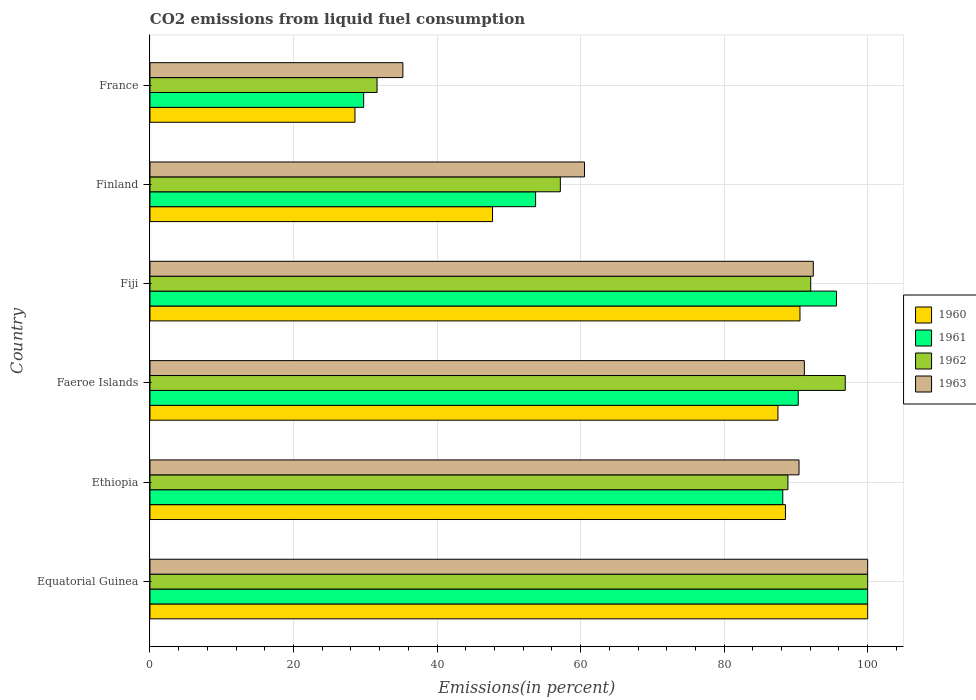How many groups of bars are there?
Make the answer very short. 6. Are the number of bars on each tick of the Y-axis equal?
Keep it short and to the point. Yes. How many bars are there on the 3rd tick from the bottom?
Give a very brief answer. 4. What is the label of the 3rd group of bars from the top?
Keep it short and to the point. Fiji. In how many cases, is the number of bars for a given country not equal to the number of legend labels?
Provide a succinct answer. 0. What is the total CO2 emitted in 1963 in France?
Offer a terse response. 35.24. Across all countries, what is the maximum total CO2 emitted in 1960?
Your response must be concise. 100. Across all countries, what is the minimum total CO2 emitted in 1962?
Offer a very short reply. 31.64. In which country was the total CO2 emitted in 1962 maximum?
Make the answer very short. Equatorial Guinea. In which country was the total CO2 emitted in 1962 minimum?
Provide a succinct answer. France. What is the total total CO2 emitted in 1960 in the graph?
Ensure brevity in your answer.  442.9. What is the difference between the total CO2 emitted in 1962 in Finland and that in France?
Make the answer very short. 25.54. What is the difference between the total CO2 emitted in 1960 in Fiji and the total CO2 emitted in 1962 in Finland?
Your answer should be compact. 33.39. What is the average total CO2 emitted in 1963 per country?
Provide a short and direct response. 78.3. What is the difference between the total CO2 emitted in 1961 and total CO2 emitted in 1962 in Finland?
Your response must be concise. -3.45. In how many countries, is the total CO2 emitted in 1963 greater than 28 %?
Your answer should be very brief. 6. What is the ratio of the total CO2 emitted in 1960 in Equatorial Guinea to that in France?
Give a very brief answer. 3.5. Is the total CO2 emitted in 1960 in Finland less than that in France?
Offer a terse response. No. Is the difference between the total CO2 emitted in 1961 in Equatorial Guinea and Fiji greater than the difference between the total CO2 emitted in 1962 in Equatorial Guinea and Fiji?
Ensure brevity in your answer.  No. What is the difference between the highest and the second highest total CO2 emitted in 1961?
Offer a very short reply. 4.35. What is the difference between the highest and the lowest total CO2 emitted in 1962?
Provide a succinct answer. 68.36. In how many countries, is the total CO2 emitted in 1961 greater than the average total CO2 emitted in 1961 taken over all countries?
Give a very brief answer. 4. What does the 4th bar from the top in Fiji represents?
Give a very brief answer. 1960. Is it the case that in every country, the sum of the total CO2 emitted in 1960 and total CO2 emitted in 1962 is greater than the total CO2 emitted in 1963?
Make the answer very short. Yes. How many bars are there?
Keep it short and to the point. 24. How many countries are there in the graph?
Make the answer very short. 6. Does the graph contain any zero values?
Give a very brief answer. No. Does the graph contain grids?
Provide a succinct answer. Yes. Where does the legend appear in the graph?
Offer a terse response. Center right. What is the title of the graph?
Ensure brevity in your answer.  CO2 emissions from liquid fuel consumption. Does "2003" appear as one of the legend labels in the graph?
Keep it short and to the point. No. What is the label or title of the X-axis?
Make the answer very short. Emissions(in percent). What is the label or title of the Y-axis?
Provide a short and direct response. Country. What is the Emissions(in percent) of 1961 in Equatorial Guinea?
Your answer should be compact. 100. What is the Emissions(in percent) of 1960 in Ethiopia?
Provide a short and direct response. 88.54. What is the Emissions(in percent) of 1961 in Ethiopia?
Provide a succinct answer. 88.17. What is the Emissions(in percent) in 1962 in Ethiopia?
Ensure brevity in your answer.  88.89. What is the Emissions(in percent) in 1963 in Ethiopia?
Your answer should be very brief. 90.43. What is the Emissions(in percent) in 1960 in Faeroe Islands?
Offer a very short reply. 87.5. What is the Emissions(in percent) of 1961 in Faeroe Islands?
Your response must be concise. 90.32. What is the Emissions(in percent) of 1962 in Faeroe Islands?
Offer a very short reply. 96.88. What is the Emissions(in percent) in 1963 in Faeroe Islands?
Provide a succinct answer. 91.18. What is the Emissions(in percent) of 1960 in Fiji?
Offer a very short reply. 90.57. What is the Emissions(in percent) in 1961 in Fiji?
Your response must be concise. 95.65. What is the Emissions(in percent) in 1962 in Fiji?
Ensure brevity in your answer.  92.06. What is the Emissions(in percent) in 1963 in Fiji?
Offer a very short reply. 92.42. What is the Emissions(in percent) of 1960 in Finland?
Offer a terse response. 47.73. What is the Emissions(in percent) of 1961 in Finland?
Keep it short and to the point. 53.73. What is the Emissions(in percent) in 1962 in Finland?
Provide a short and direct response. 57.18. What is the Emissions(in percent) in 1963 in Finland?
Give a very brief answer. 60.54. What is the Emissions(in percent) of 1960 in France?
Offer a terse response. 28.56. What is the Emissions(in percent) of 1961 in France?
Provide a short and direct response. 29.77. What is the Emissions(in percent) of 1962 in France?
Your answer should be very brief. 31.64. What is the Emissions(in percent) in 1963 in France?
Provide a short and direct response. 35.24. Across all countries, what is the maximum Emissions(in percent) of 1960?
Ensure brevity in your answer.  100. Across all countries, what is the maximum Emissions(in percent) of 1961?
Ensure brevity in your answer.  100. Across all countries, what is the maximum Emissions(in percent) of 1963?
Your response must be concise. 100. Across all countries, what is the minimum Emissions(in percent) in 1960?
Ensure brevity in your answer.  28.56. Across all countries, what is the minimum Emissions(in percent) in 1961?
Your response must be concise. 29.77. Across all countries, what is the minimum Emissions(in percent) of 1962?
Make the answer very short. 31.64. Across all countries, what is the minimum Emissions(in percent) in 1963?
Give a very brief answer. 35.24. What is the total Emissions(in percent) of 1960 in the graph?
Provide a short and direct response. 442.9. What is the total Emissions(in percent) in 1961 in the graph?
Your answer should be compact. 457.65. What is the total Emissions(in percent) of 1962 in the graph?
Provide a succinct answer. 466.64. What is the total Emissions(in percent) of 1963 in the graph?
Provide a succinct answer. 469.82. What is the difference between the Emissions(in percent) in 1960 in Equatorial Guinea and that in Ethiopia?
Offer a very short reply. 11.46. What is the difference between the Emissions(in percent) of 1961 in Equatorial Guinea and that in Ethiopia?
Keep it short and to the point. 11.83. What is the difference between the Emissions(in percent) in 1962 in Equatorial Guinea and that in Ethiopia?
Provide a short and direct response. 11.11. What is the difference between the Emissions(in percent) of 1963 in Equatorial Guinea and that in Ethiopia?
Make the answer very short. 9.57. What is the difference between the Emissions(in percent) in 1960 in Equatorial Guinea and that in Faeroe Islands?
Offer a terse response. 12.5. What is the difference between the Emissions(in percent) of 1961 in Equatorial Guinea and that in Faeroe Islands?
Offer a very short reply. 9.68. What is the difference between the Emissions(in percent) of 1962 in Equatorial Guinea and that in Faeroe Islands?
Make the answer very short. 3.12. What is the difference between the Emissions(in percent) of 1963 in Equatorial Guinea and that in Faeroe Islands?
Offer a terse response. 8.82. What is the difference between the Emissions(in percent) in 1960 in Equatorial Guinea and that in Fiji?
Offer a very short reply. 9.43. What is the difference between the Emissions(in percent) in 1961 in Equatorial Guinea and that in Fiji?
Offer a very short reply. 4.35. What is the difference between the Emissions(in percent) of 1962 in Equatorial Guinea and that in Fiji?
Make the answer very short. 7.94. What is the difference between the Emissions(in percent) in 1963 in Equatorial Guinea and that in Fiji?
Give a very brief answer. 7.58. What is the difference between the Emissions(in percent) of 1960 in Equatorial Guinea and that in Finland?
Ensure brevity in your answer.  52.27. What is the difference between the Emissions(in percent) of 1961 in Equatorial Guinea and that in Finland?
Provide a succinct answer. 46.27. What is the difference between the Emissions(in percent) in 1962 in Equatorial Guinea and that in Finland?
Provide a short and direct response. 42.82. What is the difference between the Emissions(in percent) of 1963 in Equatorial Guinea and that in Finland?
Offer a terse response. 39.46. What is the difference between the Emissions(in percent) in 1960 in Equatorial Guinea and that in France?
Your response must be concise. 71.44. What is the difference between the Emissions(in percent) of 1961 in Equatorial Guinea and that in France?
Your response must be concise. 70.23. What is the difference between the Emissions(in percent) in 1962 in Equatorial Guinea and that in France?
Ensure brevity in your answer.  68.36. What is the difference between the Emissions(in percent) of 1963 in Equatorial Guinea and that in France?
Your response must be concise. 64.76. What is the difference between the Emissions(in percent) of 1960 in Ethiopia and that in Faeroe Islands?
Ensure brevity in your answer.  1.04. What is the difference between the Emissions(in percent) in 1961 in Ethiopia and that in Faeroe Islands?
Keep it short and to the point. -2.15. What is the difference between the Emissions(in percent) in 1962 in Ethiopia and that in Faeroe Islands?
Your answer should be compact. -7.99. What is the difference between the Emissions(in percent) of 1963 in Ethiopia and that in Faeroe Islands?
Keep it short and to the point. -0.74. What is the difference between the Emissions(in percent) in 1960 in Ethiopia and that in Fiji?
Your answer should be compact. -2.02. What is the difference between the Emissions(in percent) in 1961 in Ethiopia and that in Fiji?
Your response must be concise. -7.48. What is the difference between the Emissions(in percent) in 1962 in Ethiopia and that in Fiji?
Your answer should be compact. -3.17. What is the difference between the Emissions(in percent) of 1963 in Ethiopia and that in Fiji?
Offer a very short reply. -1.99. What is the difference between the Emissions(in percent) in 1960 in Ethiopia and that in Finland?
Provide a short and direct response. 40.81. What is the difference between the Emissions(in percent) of 1961 in Ethiopia and that in Finland?
Ensure brevity in your answer.  34.44. What is the difference between the Emissions(in percent) in 1962 in Ethiopia and that in Finland?
Give a very brief answer. 31.71. What is the difference between the Emissions(in percent) in 1963 in Ethiopia and that in Finland?
Provide a succinct answer. 29.89. What is the difference between the Emissions(in percent) of 1960 in Ethiopia and that in France?
Offer a terse response. 59.98. What is the difference between the Emissions(in percent) in 1961 in Ethiopia and that in France?
Keep it short and to the point. 58.4. What is the difference between the Emissions(in percent) of 1962 in Ethiopia and that in France?
Offer a very short reply. 57.25. What is the difference between the Emissions(in percent) in 1963 in Ethiopia and that in France?
Provide a succinct answer. 55.2. What is the difference between the Emissions(in percent) in 1960 in Faeroe Islands and that in Fiji?
Your answer should be very brief. -3.07. What is the difference between the Emissions(in percent) in 1961 in Faeroe Islands and that in Fiji?
Provide a succinct answer. -5.33. What is the difference between the Emissions(in percent) in 1962 in Faeroe Islands and that in Fiji?
Offer a terse response. 4.81. What is the difference between the Emissions(in percent) in 1963 in Faeroe Islands and that in Fiji?
Make the answer very short. -1.25. What is the difference between the Emissions(in percent) in 1960 in Faeroe Islands and that in Finland?
Your answer should be compact. 39.77. What is the difference between the Emissions(in percent) in 1961 in Faeroe Islands and that in Finland?
Your answer should be compact. 36.59. What is the difference between the Emissions(in percent) in 1962 in Faeroe Islands and that in Finland?
Your answer should be compact. 39.7. What is the difference between the Emissions(in percent) in 1963 in Faeroe Islands and that in Finland?
Your response must be concise. 30.63. What is the difference between the Emissions(in percent) of 1960 in Faeroe Islands and that in France?
Your answer should be compact. 58.94. What is the difference between the Emissions(in percent) of 1961 in Faeroe Islands and that in France?
Your answer should be compact. 60.55. What is the difference between the Emissions(in percent) in 1962 in Faeroe Islands and that in France?
Your answer should be compact. 65.24. What is the difference between the Emissions(in percent) in 1963 in Faeroe Islands and that in France?
Your answer should be compact. 55.94. What is the difference between the Emissions(in percent) in 1960 in Fiji and that in Finland?
Ensure brevity in your answer.  42.84. What is the difference between the Emissions(in percent) of 1961 in Fiji and that in Finland?
Provide a short and direct response. 41.92. What is the difference between the Emissions(in percent) of 1962 in Fiji and that in Finland?
Make the answer very short. 34.89. What is the difference between the Emissions(in percent) of 1963 in Fiji and that in Finland?
Provide a short and direct response. 31.88. What is the difference between the Emissions(in percent) in 1960 in Fiji and that in France?
Your answer should be compact. 62. What is the difference between the Emissions(in percent) of 1961 in Fiji and that in France?
Your answer should be very brief. 65.88. What is the difference between the Emissions(in percent) of 1962 in Fiji and that in France?
Ensure brevity in your answer.  60.43. What is the difference between the Emissions(in percent) in 1963 in Fiji and that in France?
Your answer should be compact. 57.18. What is the difference between the Emissions(in percent) of 1960 in Finland and that in France?
Keep it short and to the point. 19.17. What is the difference between the Emissions(in percent) of 1961 in Finland and that in France?
Give a very brief answer. 23.96. What is the difference between the Emissions(in percent) in 1962 in Finland and that in France?
Your response must be concise. 25.54. What is the difference between the Emissions(in percent) of 1963 in Finland and that in France?
Your response must be concise. 25.3. What is the difference between the Emissions(in percent) in 1960 in Equatorial Guinea and the Emissions(in percent) in 1961 in Ethiopia?
Provide a short and direct response. 11.83. What is the difference between the Emissions(in percent) of 1960 in Equatorial Guinea and the Emissions(in percent) of 1962 in Ethiopia?
Ensure brevity in your answer.  11.11. What is the difference between the Emissions(in percent) of 1960 in Equatorial Guinea and the Emissions(in percent) of 1963 in Ethiopia?
Offer a terse response. 9.57. What is the difference between the Emissions(in percent) of 1961 in Equatorial Guinea and the Emissions(in percent) of 1962 in Ethiopia?
Give a very brief answer. 11.11. What is the difference between the Emissions(in percent) of 1961 in Equatorial Guinea and the Emissions(in percent) of 1963 in Ethiopia?
Make the answer very short. 9.57. What is the difference between the Emissions(in percent) of 1962 in Equatorial Guinea and the Emissions(in percent) of 1963 in Ethiopia?
Your answer should be compact. 9.57. What is the difference between the Emissions(in percent) in 1960 in Equatorial Guinea and the Emissions(in percent) in 1961 in Faeroe Islands?
Offer a very short reply. 9.68. What is the difference between the Emissions(in percent) of 1960 in Equatorial Guinea and the Emissions(in percent) of 1962 in Faeroe Islands?
Your response must be concise. 3.12. What is the difference between the Emissions(in percent) in 1960 in Equatorial Guinea and the Emissions(in percent) in 1963 in Faeroe Islands?
Your answer should be compact. 8.82. What is the difference between the Emissions(in percent) of 1961 in Equatorial Guinea and the Emissions(in percent) of 1962 in Faeroe Islands?
Offer a very short reply. 3.12. What is the difference between the Emissions(in percent) in 1961 in Equatorial Guinea and the Emissions(in percent) in 1963 in Faeroe Islands?
Your response must be concise. 8.82. What is the difference between the Emissions(in percent) in 1962 in Equatorial Guinea and the Emissions(in percent) in 1963 in Faeroe Islands?
Provide a short and direct response. 8.82. What is the difference between the Emissions(in percent) of 1960 in Equatorial Guinea and the Emissions(in percent) of 1961 in Fiji?
Ensure brevity in your answer.  4.35. What is the difference between the Emissions(in percent) in 1960 in Equatorial Guinea and the Emissions(in percent) in 1962 in Fiji?
Keep it short and to the point. 7.94. What is the difference between the Emissions(in percent) in 1960 in Equatorial Guinea and the Emissions(in percent) in 1963 in Fiji?
Provide a short and direct response. 7.58. What is the difference between the Emissions(in percent) of 1961 in Equatorial Guinea and the Emissions(in percent) of 1962 in Fiji?
Your response must be concise. 7.94. What is the difference between the Emissions(in percent) of 1961 in Equatorial Guinea and the Emissions(in percent) of 1963 in Fiji?
Ensure brevity in your answer.  7.58. What is the difference between the Emissions(in percent) of 1962 in Equatorial Guinea and the Emissions(in percent) of 1963 in Fiji?
Your answer should be compact. 7.58. What is the difference between the Emissions(in percent) of 1960 in Equatorial Guinea and the Emissions(in percent) of 1961 in Finland?
Offer a terse response. 46.27. What is the difference between the Emissions(in percent) of 1960 in Equatorial Guinea and the Emissions(in percent) of 1962 in Finland?
Your response must be concise. 42.82. What is the difference between the Emissions(in percent) of 1960 in Equatorial Guinea and the Emissions(in percent) of 1963 in Finland?
Your answer should be very brief. 39.46. What is the difference between the Emissions(in percent) in 1961 in Equatorial Guinea and the Emissions(in percent) in 1962 in Finland?
Your answer should be compact. 42.82. What is the difference between the Emissions(in percent) of 1961 in Equatorial Guinea and the Emissions(in percent) of 1963 in Finland?
Give a very brief answer. 39.46. What is the difference between the Emissions(in percent) in 1962 in Equatorial Guinea and the Emissions(in percent) in 1963 in Finland?
Provide a short and direct response. 39.46. What is the difference between the Emissions(in percent) of 1960 in Equatorial Guinea and the Emissions(in percent) of 1961 in France?
Ensure brevity in your answer.  70.23. What is the difference between the Emissions(in percent) of 1960 in Equatorial Guinea and the Emissions(in percent) of 1962 in France?
Offer a very short reply. 68.36. What is the difference between the Emissions(in percent) in 1960 in Equatorial Guinea and the Emissions(in percent) in 1963 in France?
Give a very brief answer. 64.76. What is the difference between the Emissions(in percent) of 1961 in Equatorial Guinea and the Emissions(in percent) of 1962 in France?
Your response must be concise. 68.36. What is the difference between the Emissions(in percent) in 1961 in Equatorial Guinea and the Emissions(in percent) in 1963 in France?
Your response must be concise. 64.76. What is the difference between the Emissions(in percent) in 1962 in Equatorial Guinea and the Emissions(in percent) in 1963 in France?
Offer a very short reply. 64.76. What is the difference between the Emissions(in percent) in 1960 in Ethiopia and the Emissions(in percent) in 1961 in Faeroe Islands?
Provide a short and direct response. -1.78. What is the difference between the Emissions(in percent) in 1960 in Ethiopia and the Emissions(in percent) in 1962 in Faeroe Islands?
Offer a very short reply. -8.33. What is the difference between the Emissions(in percent) in 1960 in Ethiopia and the Emissions(in percent) in 1963 in Faeroe Islands?
Offer a terse response. -2.63. What is the difference between the Emissions(in percent) of 1961 in Ethiopia and the Emissions(in percent) of 1962 in Faeroe Islands?
Your response must be concise. -8.7. What is the difference between the Emissions(in percent) in 1961 in Ethiopia and the Emissions(in percent) in 1963 in Faeroe Islands?
Your response must be concise. -3. What is the difference between the Emissions(in percent) in 1962 in Ethiopia and the Emissions(in percent) in 1963 in Faeroe Islands?
Provide a succinct answer. -2.29. What is the difference between the Emissions(in percent) of 1960 in Ethiopia and the Emissions(in percent) of 1961 in Fiji?
Your answer should be compact. -7.11. What is the difference between the Emissions(in percent) in 1960 in Ethiopia and the Emissions(in percent) in 1962 in Fiji?
Your answer should be very brief. -3.52. What is the difference between the Emissions(in percent) of 1960 in Ethiopia and the Emissions(in percent) of 1963 in Fiji?
Offer a terse response. -3.88. What is the difference between the Emissions(in percent) in 1961 in Ethiopia and the Emissions(in percent) in 1962 in Fiji?
Offer a very short reply. -3.89. What is the difference between the Emissions(in percent) in 1961 in Ethiopia and the Emissions(in percent) in 1963 in Fiji?
Keep it short and to the point. -4.25. What is the difference between the Emissions(in percent) in 1962 in Ethiopia and the Emissions(in percent) in 1963 in Fiji?
Your answer should be very brief. -3.54. What is the difference between the Emissions(in percent) of 1960 in Ethiopia and the Emissions(in percent) of 1961 in Finland?
Provide a short and direct response. 34.81. What is the difference between the Emissions(in percent) in 1960 in Ethiopia and the Emissions(in percent) in 1962 in Finland?
Offer a terse response. 31.36. What is the difference between the Emissions(in percent) of 1960 in Ethiopia and the Emissions(in percent) of 1963 in Finland?
Provide a short and direct response. 28. What is the difference between the Emissions(in percent) of 1961 in Ethiopia and the Emissions(in percent) of 1962 in Finland?
Provide a short and direct response. 30.99. What is the difference between the Emissions(in percent) in 1961 in Ethiopia and the Emissions(in percent) in 1963 in Finland?
Provide a short and direct response. 27.63. What is the difference between the Emissions(in percent) in 1962 in Ethiopia and the Emissions(in percent) in 1963 in Finland?
Keep it short and to the point. 28.35. What is the difference between the Emissions(in percent) of 1960 in Ethiopia and the Emissions(in percent) of 1961 in France?
Offer a terse response. 58.77. What is the difference between the Emissions(in percent) in 1960 in Ethiopia and the Emissions(in percent) in 1962 in France?
Make the answer very short. 56.9. What is the difference between the Emissions(in percent) in 1960 in Ethiopia and the Emissions(in percent) in 1963 in France?
Make the answer very short. 53.3. What is the difference between the Emissions(in percent) of 1961 in Ethiopia and the Emissions(in percent) of 1962 in France?
Keep it short and to the point. 56.53. What is the difference between the Emissions(in percent) of 1961 in Ethiopia and the Emissions(in percent) of 1963 in France?
Offer a very short reply. 52.93. What is the difference between the Emissions(in percent) in 1962 in Ethiopia and the Emissions(in percent) in 1963 in France?
Your answer should be compact. 53.65. What is the difference between the Emissions(in percent) in 1960 in Faeroe Islands and the Emissions(in percent) in 1961 in Fiji?
Give a very brief answer. -8.15. What is the difference between the Emissions(in percent) of 1960 in Faeroe Islands and the Emissions(in percent) of 1962 in Fiji?
Your answer should be very brief. -4.56. What is the difference between the Emissions(in percent) of 1960 in Faeroe Islands and the Emissions(in percent) of 1963 in Fiji?
Ensure brevity in your answer.  -4.92. What is the difference between the Emissions(in percent) in 1961 in Faeroe Islands and the Emissions(in percent) in 1962 in Fiji?
Give a very brief answer. -1.74. What is the difference between the Emissions(in percent) of 1961 in Faeroe Islands and the Emissions(in percent) of 1963 in Fiji?
Your response must be concise. -2.1. What is the difference between the Emissions(in percent) in 1962 in Faeroe Islands and the Emissions(in percent) in 1963 in Fiji?
Provide a short and direct response. 4.45. What is the difference between the Emissions(in percent) in 1960 in Faeroe Islands and the Emissions(in percent) in 1961 in Finland?
Your answer should be very brief. 33.77. What is the difference between the Emissions(in percent) of 1960 in Faeroe Islands and the Emissions(in percent) of 1962 in Finland?
Offer a terse response. 30.32. What is the difference between the Emissions(in percent) of 1960 in Faeroe Islands and the Emissions(in percent) of 1963 in Finland?
Make the answer very short. 26.96. What is the difference between the Emissions(in percent) of 1961 in Faeroe Islands and the Emissions(in percent) of 1962 in Finland?
Give a very brief answer. 33.15. What is the difference between the Emissions(in percent) of 1961 in Faeroe Islands and the Emissions(in percent) of 1963 in Finland?
Give a very brief answer. 29.78. What is the difference between the Emissions(in percent) in 1962 in Faeroe Islands and the Emissions(in percent) in 1963 in Finland?
Provide a succinct answer. 36.33. What is the difference between the Emissions(in percent) in 1960 in Faeroe Islands and the Emissions(in percent) in 1961 in France?
Your answer should be very brief. 57.73. What is the difference between the Emissions(in percent) in 1960 in Faeroe Islands and the Emissions(in percent) in 1962 in France?
Your answer should be compact. 55.86. What is the difference between the Emissions(in percent) of 1960 in Faeroe Islands and the Emissions(in percent) of 1963 in France?
Keep it short and to the point. 52.26. What is the difference between the Emissions(in percent) in 1961 in Faeroe Islands and the Emissions(in percent) in 1962 in France?
Ensure brevity in your answer.  58.69. What is the difference between the Emissions(in percent) in 1961 in Faeroe Islands and the Emissions(in percent) in 1963 in France?
Ensure brevity in your answer.  55.08. What is the difference between the Emissions(in percent) in 1962 in Faeroe Islands and the Emissions(in percent) in 1963 in France?
Offer a very short reply. 61.64. What is the difference between the Emissions(in percent) in 1960 in Fiji and the Emissions(in percent) in 1961 in Finland?
Your response must be concise. 36.84. What is the difference between the Emissions(in percent) in 1960 in Fiji and the Emissions(in percent) in 1962 in Finland?
Keep it short and to the point. 33.39. What is the difference between the Emissions(in percent) of 1960 in Fiji and the Emissions(in percent) of 1963 in Finland?
Your answer should be compact. 30.02. What is the difference between the Emissions(in percent) of 1961 in Fiji and the Emissions(in percent) of 1962 in Finland?
Provide a succinct answer. 38.48. What is the difference between the Emissions(in percent) of 1961 in Fiji and the Emissions(in percent) of 1963 in Finland?
Offer a very short reply. 35.11. What is the difference between the Emissions(in percent) of 1962 in Fiji and the Emissions(in percent) of 1963 in Finland?
Keep it short and to the point. 31.52. What is the difference between the Emissions(in percent) in 1960 in Fiji and the Emissions(in percent) in 1961 in France?
Keep it short and to the point. 60.79. What is the difference between the Emissions(in percent) in 1960 in Fiji and the Emissions(in percent) in 1962 in France?
Provide a succinct answer. 58.93. What is the difference between the Emissions(in percent) of 1960 in Fiji and the Emissions(in percent) of 1963 in France?
Offer a very short reply. 55.33. What is the difference between the Emissions(in percent) of 1961 in Fiji and the Emissions(in percent) of 1962 in France?
Your answer should be compact. 64.02. What is the difference between the Emissions(in percent) of 1961 in Fiji and the Emissions(in percent) of 1963 in France?
Offer a very short reply. 60.41. What is the difference between the Emissions(in percent) of 1962 in Fiji and the Emissions(in percent) of 1963 in France?
Keep it short and to the point. 56.82. What is the difference between the Emissions(in percent) of 1960 in Finland and the Emissions(in percent) of 1961 in France?
Provide a short and direct response. 17.96. What is the difference between the Emissions(in percent) in 1960 in Finland and the Emissions(in percent) in 1962 in France?
Keep it short and to the point. 16.09. What is the difference between the Emissions(in percent) in 1960 in Finland and the Emissions(in percent) in 1963 in France?
Your response must be concise. 12.49. What is the difference between the Emissions(in percent) of 1961 in Finland and the Emissions(in percent) of 1962 in France?
Your answer should be very brief. 22.09. What is the difference between the Emissions(in percent) of 1961 in Finland and the Emissions(in percent) of 1963 in France?
Your response must be concise. 18.49. What is the difference between the Emissions(in percent) of 1962 in Finland and the Emissions(in percent) of 1963 in France?
Your answer should be very brief. 21.94. What is the average Emissions(in percent) of 1960 per country?
Ensure brevity in your answer.  73.82. What is the average Emissions(in percent) of 1961 per country?
Provide a succinct answer. 76.28. What is the average Emissions(in percent) of 1962 per country?
Your answer should be compact. 77.77. What is the average Emissions(in percent) of 1963 per country?
Ensure brevity in your answer.  78.3. What is the difference between the Emissions(in percent) in 1960 and Emissions(in percent) in 1961 in Equatorial Guinea?
Your answer should be very brief. 0. What is the difference between the Emissions(in percent) of 1960 and Emissions(in percent) of 1962 in Equatorial Guinea?
Provide a short and direct response. 0. What is the difference between the Emissions(in percent) in 1961 and Emissions(in percent) in 1963 in Equatorial Guinea?
Ensure brevity in your answer.  0. What is the difference between the Emissions(in percent) in 1962 and Emissions(in percent) in 1963 in Equatorial Guinea?
Provide a short and direct response. 0. What is the difference between the Emissions(in percent) of 1960 and Emissions(in percent) of 1961 in Ethiopia?
Ensure brevity in your answer.  0.37. What is the difference between the Emissions(in percent) of 1960 and Emissions(in percent) of 1962 in Ethiopia?
Give a very brief answer. -0.35. What is the difference between the Emissions(in percent) of 1960 and Emissions(in percent) of 1963 in Ethiopia?
Ensure brevity in your answer.  -1.89. What is the difference between the Emissions(in percent) in 1961 and Emissions(in percent) in 1962 in Ethiopia?
Ensure brevity in your answer.  -0.72. What is the difference between the Emissions(in percent) of 1961 and Emissions(in percent) of 1963 in Ethiopia?
Make the answer very short. -2.26. What is the difference between the Emissions(in percent) of 1962 and Emissions(in percent) of 1963 in Ethiopia?
Make the answer very short. -1.55. What is the difference between the Emissions(in percent) of 1960 and Emissions(in percent) of 1961 in Faeroe Islands?
Make the answer very short. -2.82. What is the difference between the Emissions(in percent) of 1960 and Emissions(in percent) of 1962 in Faeroe Islands?
Provide a short and direct response. -9.38. What is the difference between the Emissions(in percent) in 1960 and Emissions(in percent) in 1963 in Faeroe Islands?
Your response must be concise. -3.68. What is the difference between the Emissions(in percent) in 1961 and Emissions(in percent) in 1962 in Faeroe Islands?
Your response must be concise. -6.55. What is the difference between the Emissions(in percent) of 1961 and Emissions(in percent) of 1963 in Faeroe Islands?
Your response must be concise. -0.85. What is the difference between the Emissions(in percent) in 1962 and Emissions(in percent) in 1963 in Faeroe Islands?
Provide a succinct answer. 5.7. What is the difference between the Emissions(in percent) of 1960 and Emissions(in percent) of 1961 in Fiji?
Give a very brief answer. -5.09. What is the difference between the Emissions(in percent) in 1960 and Emissions(in percent) in 1962 in Fiji?
Give a very brief answer. -1.5. What is the difference between the Emissions(in percent) in 1960 and Emissions(in percent) in 1963 in Fiji?
Make the answer very short. -1.86. What is the difference between the Emissions(in percent) of 1961 and Emissions(in percent) of 1962 in Fiji?
Offer a terse response. 3.59. What is the difference between the Emissions(in percent) of 1961 and Emissions(in percent) of 1963 in Fiji?
Offer a very short reply. 3.23. What is the difference between the Emissions(in percent) in 1962 and Emissions(in percent) in 1963 in Fiji?
Ensure brevity in your answer.  -0.36. What is the difference between the Emissions(in percent) of 1960 and Emissions(in percent) of 1961 in Finland?
Make the answer very short. -6. What is the difference between the Emissions(in percent) in 1960 and Emissions(in percent) in 1962 in Finland?
Your answer should be very brief. -9.45. What is the difference between the Emissions(in percent) in 1960 and Emissions(in percent) in 1963 in Finland?
Give a very brief answer. -12.81. What is the difference between the Emissions(in percent) in 1961 and Emissions(in percent) in 1962 in Finland?
Provide a short and direct response. -3.45. What is the difference between the Emissions(in percent) in 1961 and Emissions(in percent) in 1963 in Finland?
Provide a succinct answer. -6.81. What is the difference between the Emissions(in percent) of 1962 and Emissions(in percent) of 1963 in Finland?
Your answer should be compact. -3.36. What is the difference between the Emissions(in percent) of 1960 and Emissions(in percent) of 1961 in France?
Make the answer very short. -1.21. What is the difference between the Emissions(in percent) of 1960 and Emissions(in percent) of 1962 in France?
Give a very brief answer. -3.07. What is the difference between the Emissions(in percent) of 1960 and Emissions(in percent) of 1963 in France?
Provide a succinct answer. -6.68. What is the difference between the Emissions(in percent) in 1961 and Emissions(in percent) in 1962 in France?
Your answer should be very brief. -1.86. What is the difference between the Emissions(in percent) of 1961 and Emissions(in percent) of 1963 in France?
Keep it short and to the point. -5.47. What is the difference between the Emissions(in percent) of 1962 and Emissions(in percent) of 1963 in France?
Give a very brief answer. -3.6. What is the ratio of the Emissions(in percent) of 1960 in Equatorial Guinea to that in Ethiopia?
Offer a terse response. 1.13. What is the ratio of the Emissions(in percent) of 1961 in Equatorial Guinea to that in Ethiopia?
Make the answer very short. 1.13. What is the ratio of the Emissions(in percent) in 1963 in Equatorial Guinea to that in Ethiopia?
Your response must be concise. 1.11. What is the ratio of the Emissions(in percent) of 1960 in Equatorial Guinea to that in Faeroe Islands?
Your answer should be very brief. 1.14. What is the ratio of the Emissions(in percent) of 1961 in Equatorial Guinea to that in Faeroe Islands?
Give a very brief answer. 1.11. What is the ratio of the Emissions(in percent) of 1962 in Equatorial Guinea to that in Faeroe Islands?
Provide a short and direct response. 1.03. What is the ratio of the Emissions(in percent) of 1963 in Equatorial Guinea to that in Faeroe Islands?
Ensure brevity in your answer.  1.1. What is the ratio of the Emissions(in percent) in 1960 in Equatorial Guinea to that in Fiji?
Offer a terse response. 1.1. What is the ratio of the Emissions(in percent) of 1961 in Equatorial Guinea to that in Fiji?
Offer a very short reply. 1.05. What is the ratio of the Emissions(in percent) in 1962 in Equatorial Guinea to that in Fiji?
Make the answer very short. 1.09. What is the ratio of the Emissions(in percent) in 1963 in Equatorial Guinea to that in Fiji?
Your answer should be compact. 1.08. What is the ratio of the Emissions(in percent) of 1960 in Equatorial Guinea to that in Finland?
Provide a short and direct response. 2.1. What is the ratio of the Emissions(in percent) in 1961 in Equatorial Guinea to that in Finland?
Your answer should be very brief. 1.86. What is the ratio of the Emissions(in percent) of 1962 in Equatorial Guinea to that in Finland?
Give a very brief answer. 1.75. What is the ratio of the Emissions(in percent) in 1963 in Equatorial Guinea to that in Finland?
Keep it short and to the point. 1.65. What is the ratio of the Emissions(in percent) of 1960 in Equatorial Guinea to that in France?
Provide a short and direct response. 3.5. What is the ratio of the Emissions(in percent) in 1961 in Equatorial Guinea to that in France?
Offer a very short reply. 3.36. What is the ratio of the Emissions(in percent) in 1962 in Equatorial Guinea to that in France?
Your answer should be compact. 3.16. What is the ratio of the Emissions(in percent) in 1963 in Equatorial Guinea to that in France?
Offer a terse response. 2.84. What is the ratio of the Emissions(in percent) of 1960 in Ethiopia to that in Faeroe Islands?
Make the answer very short. 1.01. What is the ratio of the Emissions(in percent) of 1961 in Ethiopia to that in Faeroe Islands?
Provide a short and direct response. 0.98. What is the ratio of the Emissions(in percent) in 1962 in Ethiopia to that in Faeroe Islands?
Ensure brevity in your answer.  0.92. What is the ratio of the Emissions(in percent) of 1960 in Ethiopia to that in Fiji?
Your answer should be compact. 0.98. What is the ratio of the Emissions(in percent) in 1961 in Ethiopia to that in Fiji?
Offer a terse response. 0.92. What is the ratio of the Emissions(in percent) in 1962 in Ethiopia to that in Fiji?
Give a very brief answer. 0.97. What is the ratio of the Emissions(in percent) in 1963 in Ethiopia to that in Fiji?
Provide a short and direct response. 0.98. What is the ratio of the Emissions(in percent) in 1960 in Ethiopia to that in Finland?
Provide a succinct answer. 1.86. What is the ratio of the Emissions(in percent) of 1961 in Ethiopia to that in Finland?
Your answer should be very brief. 1.64. What is the ratio of the Emissions(in percent) of 1962 in Ethiopia to that in Finland?
Provide a succinct answer. 1.55. What is the ratio of the Emissions(in percent) of 1963 in Ethiopia to that in Finland?
Provide a short and direct response. 1.49. What is the ratio of the Emissions(in percent) in 1960 in Ethiopia to that in France?
Your response must be concise. 3.1. What is the ratio of the Emissions(in percent) of 1961 in Ethiopia to that in France?
Your answer should be compact. 2.96. What is the ratio of the Emissions(in percent) in 1962 in Ethiopia to that in France?
Your answer should be very brief. 2.81. What is the ratio of the Emissions(in percent) in 1963 in Ethiopia to that in France?
Your answer should be very brief. 2.57. What is the ratio of the Emissions(in percent) of 1960 in Faeroe Islands to that in Fiji?
Ensure brevity in your answer.  0.97. What is the ratio of the Emissions(in percent) in 1961 in Faeroe Islands to that in Fiji?
Keep it short and to the point. 0.94. What is the ratio of the Emissions(in percent) in 1962 in Faeroe Islands to that in Fiji?
Your response must be concise. 1.05. What is the ratio of the Emissions(in percent) in 1963 in Faeroe Islands to that in Fiji?
Offer a terse response. 0.99. What is the ratio of the Emissions(in percent) of 1960 in Faeroe Islands to that in Finland?
Provide a short and direct response. 1.83. What is the ratio of the Emissions(in percent) of 1961 in Faeroe Islands to that in Finland?
Offer a very short reply. 1.68. What is the ratio of the Emissions(in percent) of 1962 in Faeroe Islands to that in Finland?
Ensure brevity in your answer.  1.69. What is the ratio of the Emissions(in percent) of 1963 in Faeroe Islands to that in Finland?
Offer a terse response. 1.51. What is the ratio of the Emissions(in percent) in 1960 in Faeroe Islands to that in France?
Offer a very short reply. 3.06. What is the ratio of the Emissions(in percent) of 1961 in Faeroe Islands to that in France?
Your answer should be compact. 3.03. What is the ratio of the Emissions(in percent) in 1962 in Faeroe Islands to that in France?
Offer a very short reply. 3.06. What is the ratio of the Emissions(in percent) of 1963 in Faeroe Islands to that in France?
Keep it short and to the point. 2.59. What is the ratio of the Emissions(in percent) in 1960 in Fiji to that in Finland?
Offer a very short reply. 1.9. What is the ratio of the Emissions(in percent) in 1961 in Fiji to that in Finland?
Provide a short and direct response. 1.78. What is the ratio of the Emissions(in percent) of 1962 in Fiji to that in Finland?
Make the answer very short. 1.61. What is the ratio of the Emissions(in percent) of 1963 in Fiji to that in Finland?
Your response must be concise. 1.53. What is the ratio of the Emissions(in percent) in 1960 in Fiji to that in France?
Keep it short and to the point. 3.17. What is the ratio of the Emissions(in percent) of 1961 in Fiji to that in France?
Give a very brief answer. 3.21. What is the ratio of the Emissions(in percent) of 1962 in Fiji to that in France?
Make the answer very short. 2.91. What is the ratio of the Emissions(in percent) in 1963 in Fiji to that in France?
Provide a succinct answer. 2.62. What is the ratio of the Emissions(in percent) in 1960 in Finland to that in France?
Provide a succinct answer. 1.67. What is the ratio of the Emissions(in percent) in 1961 in Finland to that in France?
Your response must be concise. 1.8. What is the ratio of the Emissions(in percent) of 1962 in Finland to that in France?
Give a very brief answer. 1.81. What is the ratio of the Emissions(in percent) of 1963 in Finland to that in France?
Provide a succinct answer. 1.72. What is the difference between the highest and the second highest Emissions(in percent) of 1960?
Offer a terse response. 9.43. What is the difference between the highest and the second highest Emissions(in percent) in 1961?
Your response must be concise. 4.35. What is the difference between the highest and the second highest Emissions(in percent) of 1962?
Keep it short and to the point. 3.12. What is the difference between the highest and the second highest Emissions(in percent) of 1963?
Keep it short and to the point. 7.58. What is the difference between the highest and the lowest Emissions(in percent) of 1960?
Provide a short and direct response. 71.44. What is the difference between the highest and the lowest Emissions(in percent) of 1961?
Make the answer very short. 70.23. What is the difference between the highest and the lowest Emissions(in percent) in 1962?
Offer a very short reply. 68.36. What is the difference between the highest and the lowest Emissions(in percent) in 1963?
Provide a succinct answer. 64.76. 